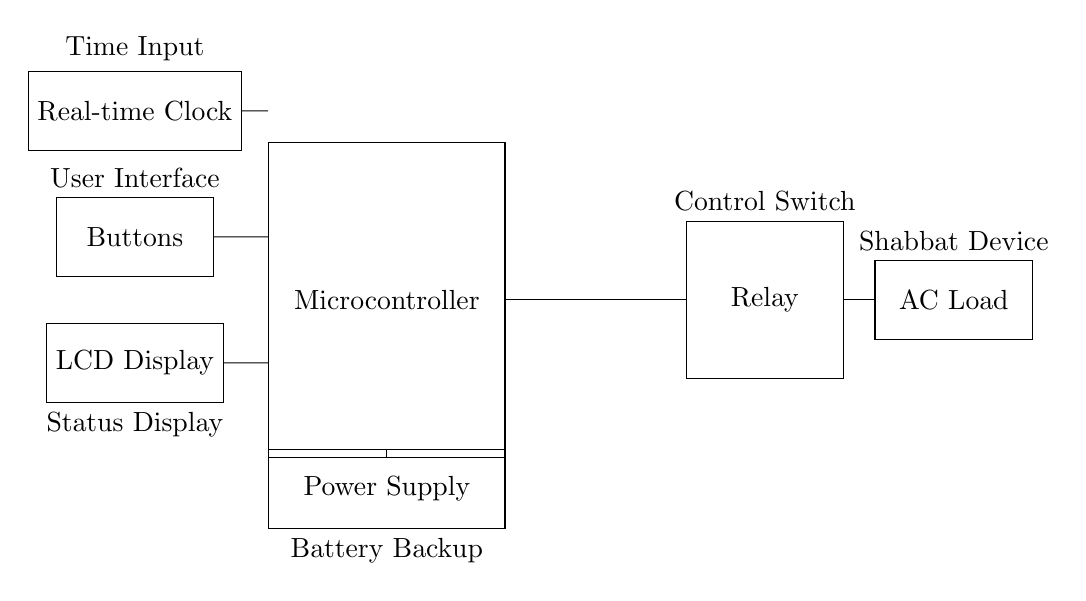what is the main component of the circuit? The main component is the microcontroller, which processes input and controls the relay for the AC load.
Answer: microcontroller how many buttons are in the circuit? There is one button module represented in the circuit, which allows user interaction to set the timer.
Answer: one what does the relay do in this circuit? The relay acts as a control switch that connects or disconnects the AC load based on the microcontroller's signals.
Answer: control switch what is the purpose of the real-time clock? The real-time clock keeps track of the current time to ensure that the timer operates correctly, especially for Shabbat timing.
Answer: timekeeping how does the power supply connect to the microcontroller? The power supply connects directly to the microcontroller providing necessary power for its operation.
Answer: directly which component provides the user interface? The buttons component provides a user interface, allowing users to input and set the timer for the Shabbat device.
Answer: buttons what is the function of the LCD display? The LCD display shows the status of the timer and provides feedback to the user regarding the time settings.
Answer: status display 